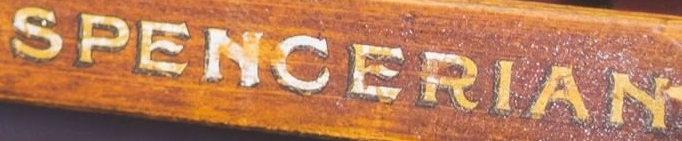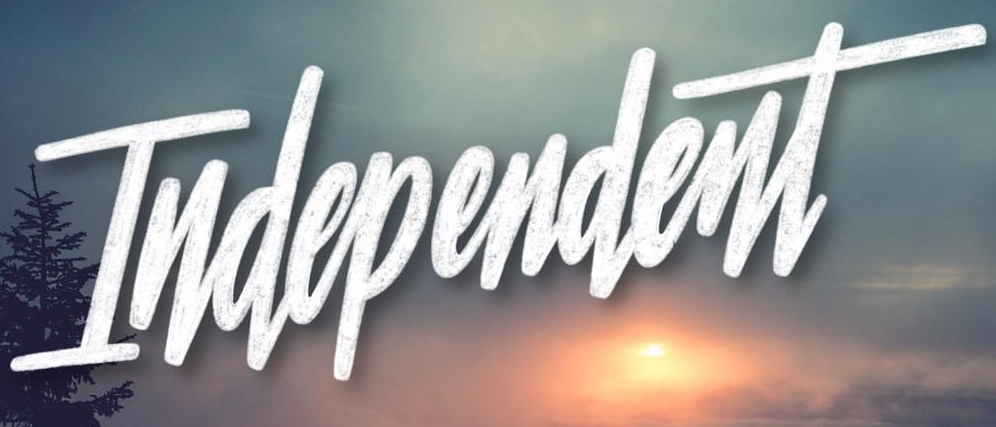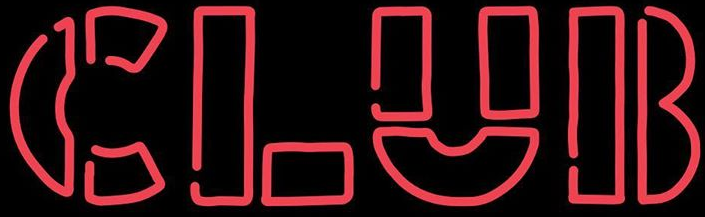What words can you see in these images in sequence, separated by a semicolon? SPENCERIAN; Independent; CLUB 